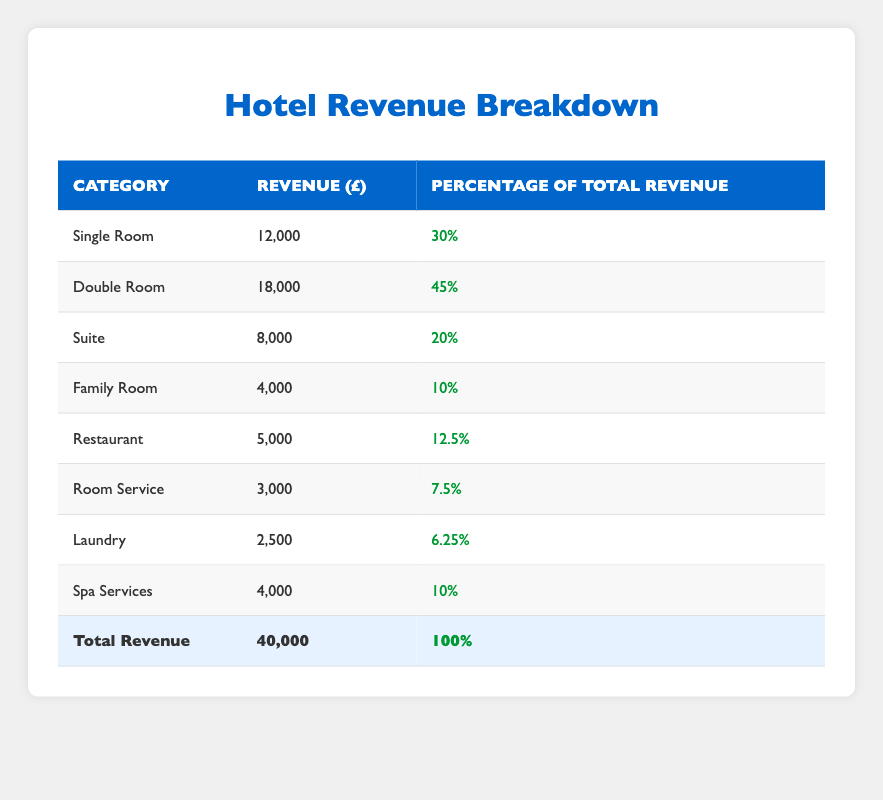What is the total revenue generated from all room types? By referring to the total revenue listed in the table, we see the total revenue is £40,000.
Answer: £40,000 Which room type generates the highest revenue? Looking at the revenue column for each room type, the Double Room has the highest revenue of £18,000, compared to Single Room £12,000, Suite £8,000, and Family Room £4,000.
Answer: Double Room What percentage of the total revenue comes from ancillary services? The total revenue is £40,000. Ancillary services generate £5,000 (Restaurant) + £3,000 (Room Service) + £2,500 (Laundry) + £4,000 (Spa Services) = £14,500. Therefore, the percentage is (14,500/40,000) * 100 = 36.25%.
Answer: 36.25% Is the revenue from Suites less than the revenue from Family Rooms? The revenue from Suites is £8,000, while the revenue from Family Rooms is £4,000. Since £8,000 is greater than £4,000, this statement is false.
Answer: No How much revenue do Double Rooms and Spa Services generate together? The revenue from Double Rooms is £18,000 and from Spa Services is £4,000. Adding these gives £18,000 + £4,000 = £22,000.
Answer: £22,000 What is the average revenue of the room types? The room types generate £12,000 (Single Room) + £18,000 (Double Room) + £8,000 (Suite) + £4,000 (Family Room) = £42,000. There are 4 room types, hence average revenue = £42,000 / 4 = £10,500.
Answer: £10,500 Does the revenue from Room Service account for more than 10% of total revenue? The Room Service revenue is £3,000. The total revenue is £40,000, so the percentage is (3,000/40,000) * 100 = 7.5%. Since 7.5% is not more than 10%, this is false.
Answer: No Which revenue segment contributes more: room types or ancillary services? The total revenue from room types is £40,000 - £14,500 (from ancillary services, calculated earlier) = £25,500. Since £25,500 (room types) is greater than £14,500 (ancillary services), room types contribute more.
Answer: Room types 